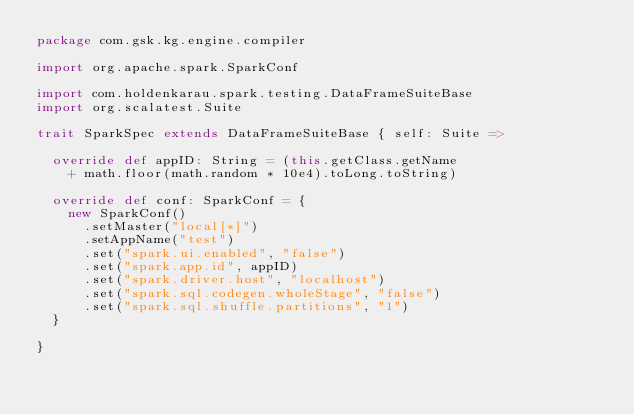Convert code to text. <code><loc_0><loc_0><loc_500><loc_500><_Scala_>package com.gsk.kg.engine.compiler

import org.apache.spark.SparkConf

import com.holdenkarau.spark.testing.DataFrameSuiteBase
import org.scalatest.Suite

trait SparkSpec extends DataFrameSuiteBase { self: Suite =>

  override def appID: String = (this.getClass.getName
    + math.floor(math.random * 10e4).toLong.toString)

  override def conf: SparkConf = {
    new SparkConf()
      .setMaster("local[*]")
      .setAppName("test")
      .set("spark.ui.enabled", "false")
      .set("spark.app.id", appID)
      .set("spark.driver.host", "localhost")
      .set("spark.sql.codegen.wholeStage", "false")
      .set("spark.sql.shuffle.partitions", "1")
  }

}
</code> 